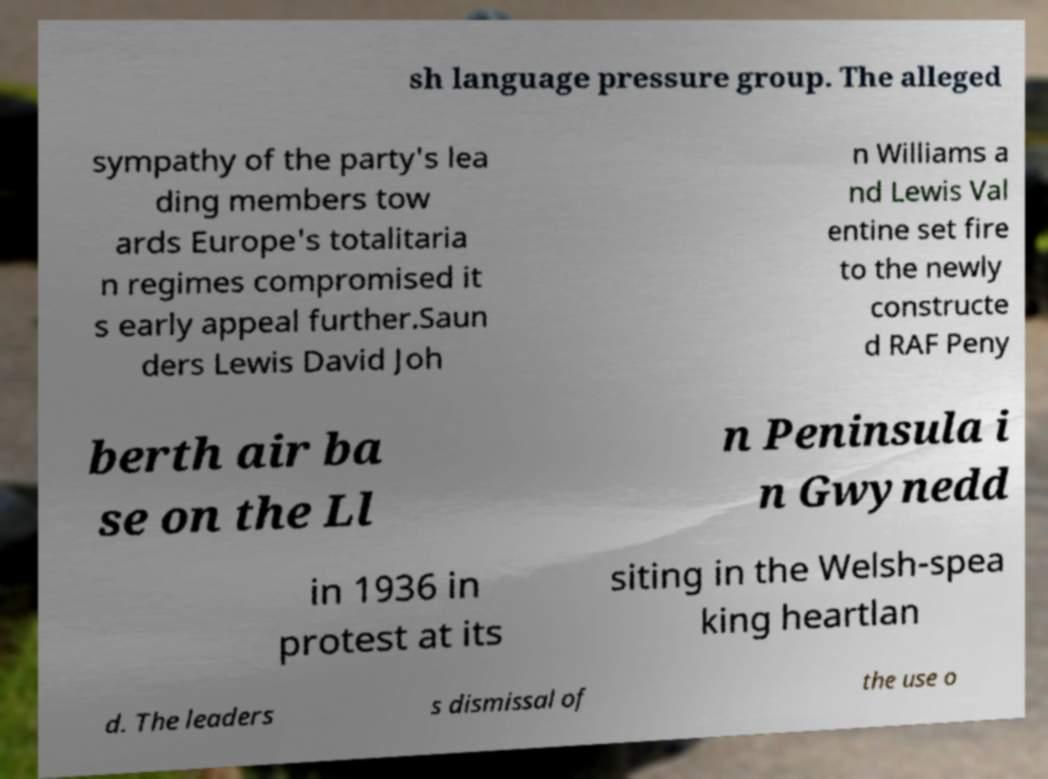For documentation purposes, I need the text within this image transcribed. Could you provide that? sh language pressure group. The alleged sympathy of the party's lea ding members tow ards Europe's totalitaria n regimes compromised it s early appeal further.Saun ders Lewis David Joh n Williams a nd Lewis Val entine set fire to the newly constructe d RAF Peny berth air ba se on the Ll n Peninsula i n Gwynedd in 1936 in protest at its siting in the Welsh-spea king heartlan d. The leaders s dismissal of the use o 